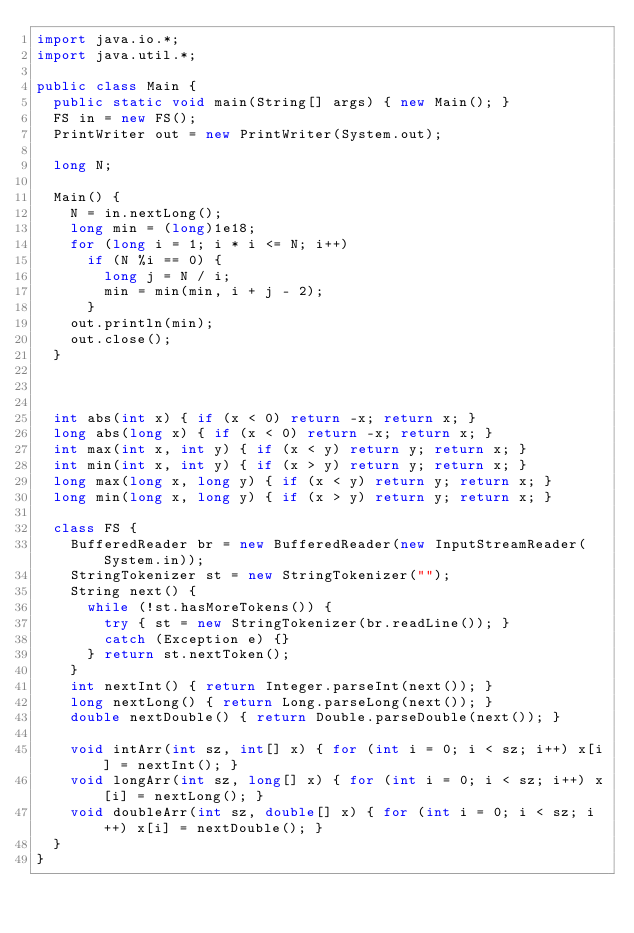Convert code to text. <code><loc_0><loc_0><loc_500><loc_500><_Java_>import java.io.*;
import java.util.*;

public class Main {
	public static void main(String[] args) { new Main(); }
	FS in = new FS();
	PrintWriter out = new PrintWriter(System.out);

	long N;	
	
	Main() {
		N = in.nextLong();
		long min = (long)1e18;
		for (long i = 1; i * i <= N; i++)
			if (N %i == 0) {
				long j = N / i;
				min = min(min, i + j - 2);
			}
		out.println(min);
		out.close();
	}

	
	
	int abs(int x) { if (x < 0) return -x; return x; }
	long abs(long x) { if (x < 0) return -x; return x; }
	int max(int x, int y) { if (x < y) return y; return x; }
	int min(int x, int y) { if (x > y) return y; return x; }
	long max(long x, long y) { if (x < y) return y; return x; }
	long min(long x, long y) { if (x > y) return y; return x; }

	class FS {
		BufferedReader br = new BufferedReader(new InputStreamReader(System.in));
		StringTokenizer st = new StringTokenizer("");
		String next() {
			while (!st.hasMoreTokens()) {
				try { st = new StringTokenizer(br.readLine()); }
				catch (Exception e) {}
			} return st.nextToken();
		}
		int nextInt() { return Integer.parseInt(next()); }
		long nextLong() { return Long.parseLong(next()); }
		double nextDouble() { return Double.parseDouble(next()); }

		void intArr(int sz, int[] x) { for (int i = 0; i < sz; i++) x[i] = nextInt(); }
		void longArr(int sz, long[] x) { for (int i = 0; i < sz; i++) x[i] = nextLong(); }
		void doubleArr(int sz, double[] x) { for (int i = 0; i < sz; i++) x[i] = nextDouble(); }
	}
}

</code> 